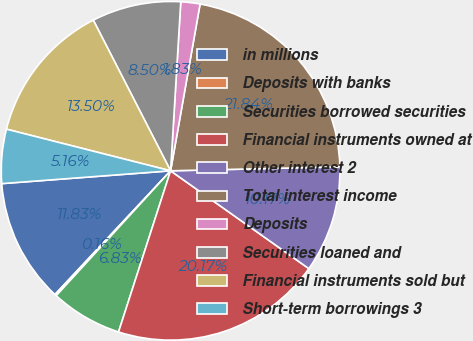Convert chart. <chart><loc_0><loc_0><loc_500><loc_500><pie_chart><fcel>in millions<fcel>Deposits with banks<fcel>Securities borrowed securities<fcel>Financial instruments owned at<fcel>Other interest 2<fcel>Total interest income<fcel>Deposits<fcel>Securities loaned and<fcel>Financial instruments sold but<fcel>Short-term borrowings 3<nl><fcel>11.83%<fcel>0.16%<fcel>6.83%<fcel>20.17%<fcel>10.17%<fcel>21.84%<fcel>1.83%<fcel>8.5%<fcel>13.5%<fcel>5.16%<nl></chart> 